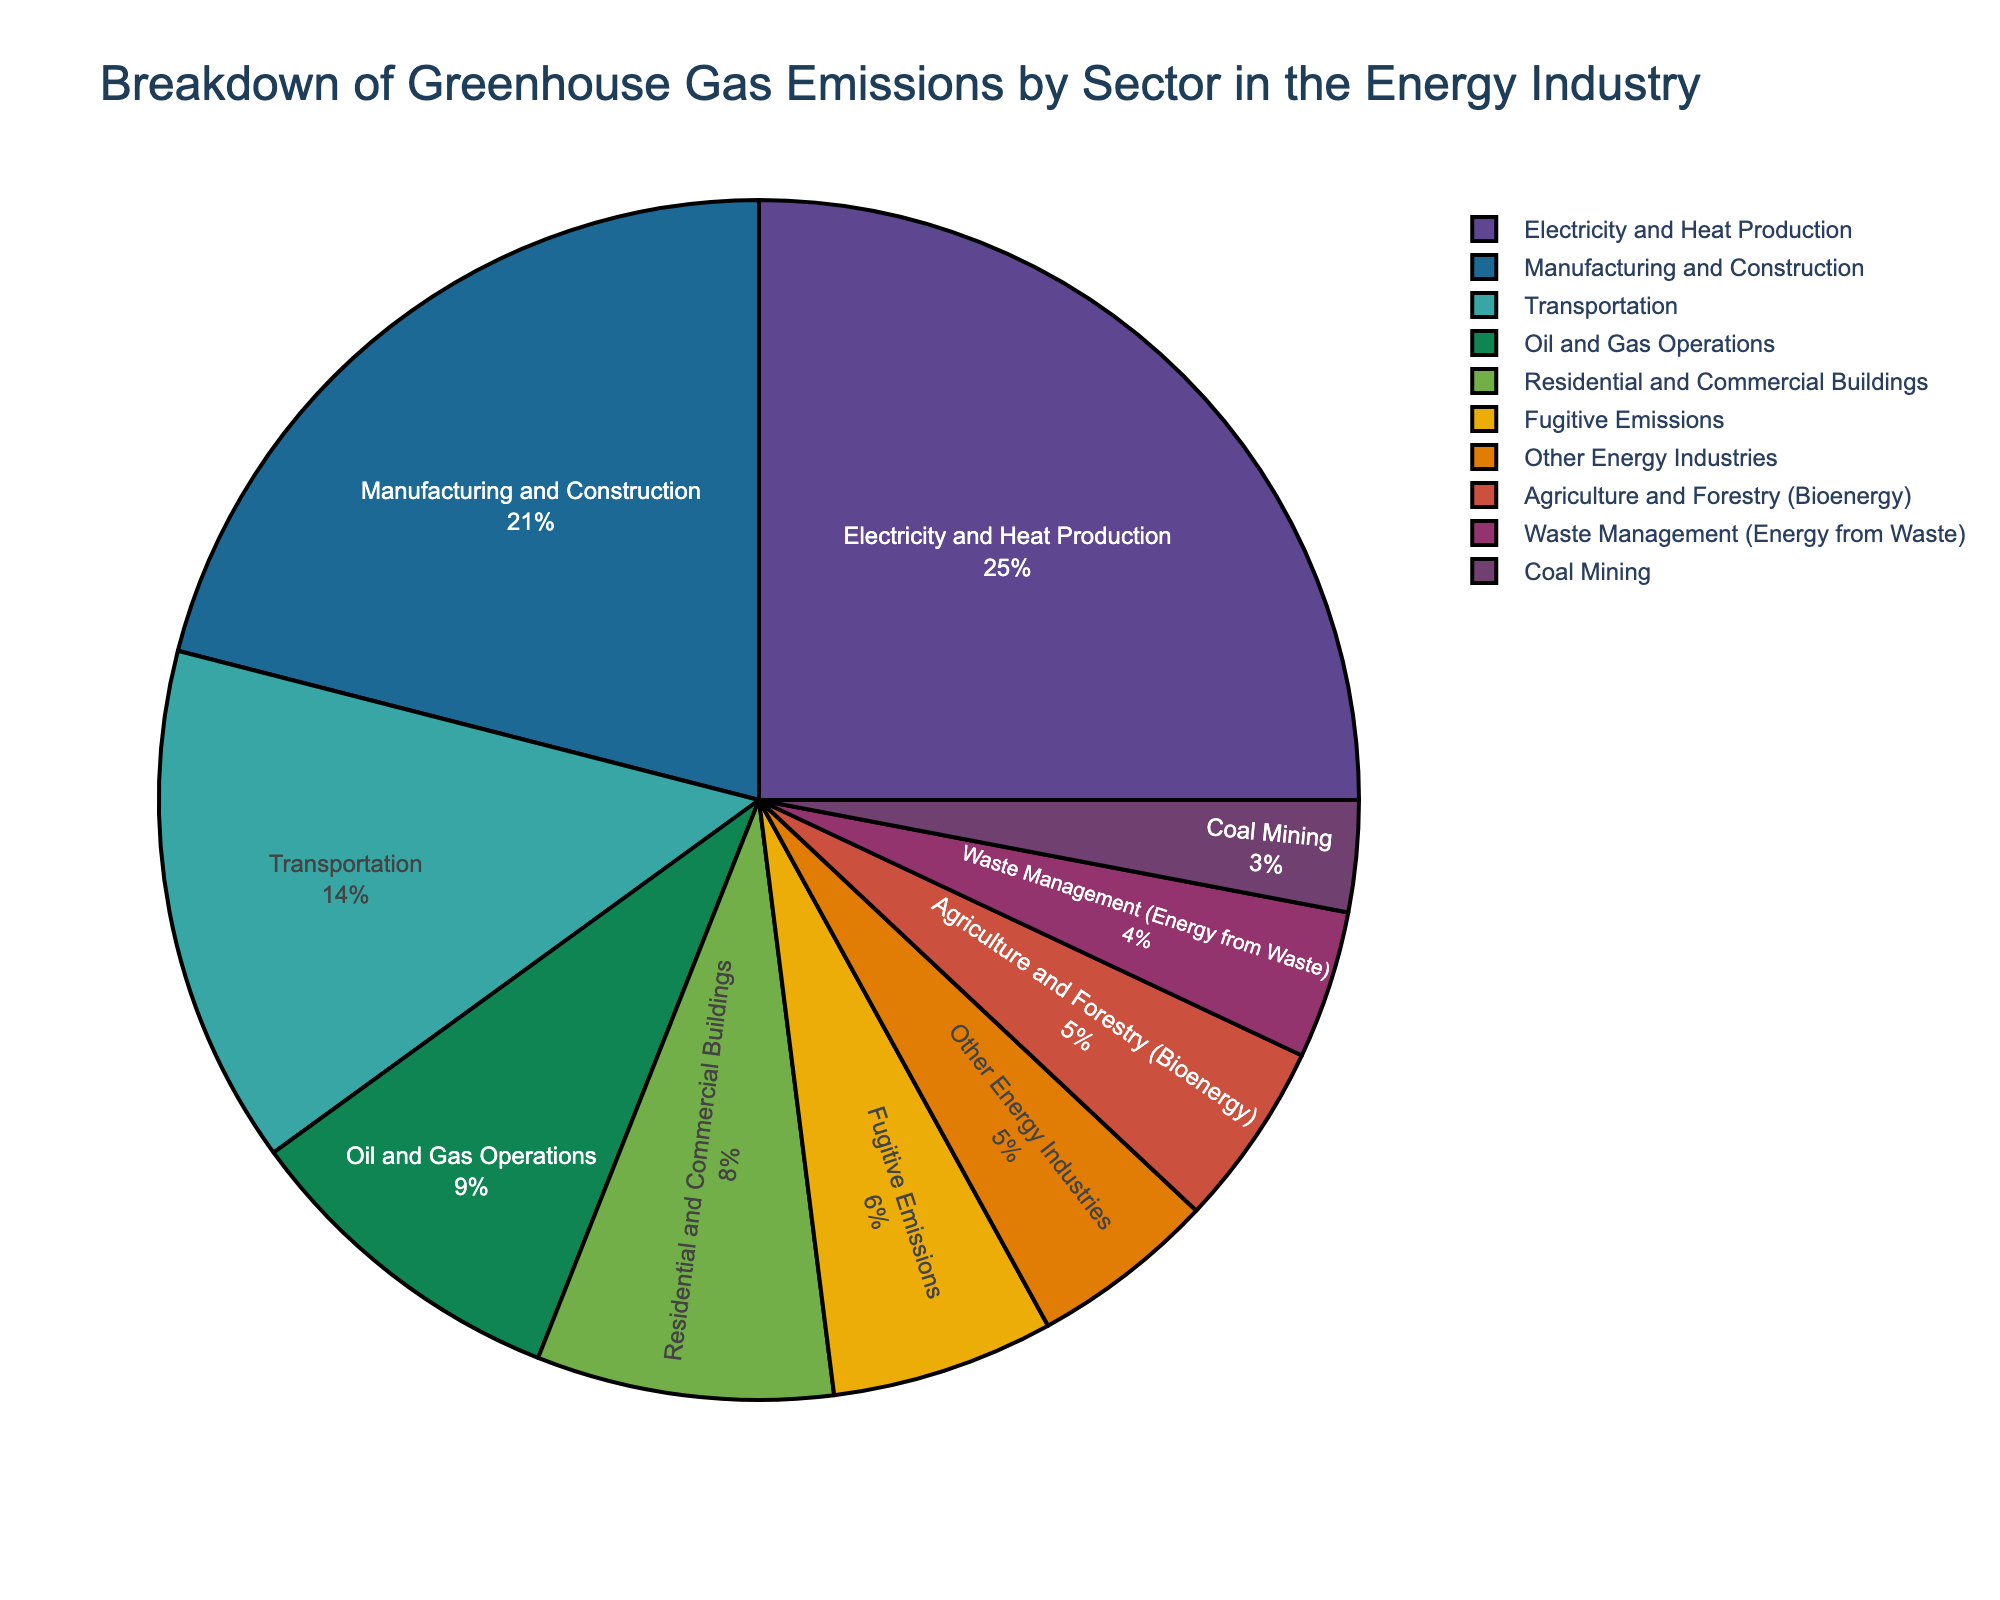Which sector contributes the most to greenhouse gas emissions in the energy industry? The sector contributing the most can be determined by identifying the largest slice in the pie chart, which belongs to the "Electricity and Heat Production" sector.
Answer: Electricity and Heat Production Which sectors contribute less than 10% of the greenhouse gas emissions each? From the pie chart, we identify all sectors with a percentage less than 10%. These sectors are "Fugitive Emissions", "Coal Mining", "Other Energy Industries", "Agriculture and Forestry (Bioenergy)", and "Waste Management (Energy from Waste)".
Answer: Fugitive Emissions, Coal Mining, Other Energy Industries, Agriculture and Forestry (Bioenergy), Waste Management (Energy from Waste) What is the combined percentage of greenhouse gas emissions from the "Transportation" and "Residential and Commercial Buildings" sectors? We sum the percentages of the "Transportation" (14%) and "Residential and Commercial Buildings" (8%) sectors. The combined percentage is 14 + 8 = 22%.
Answer: 22% How much greater is the percentage of emissions from "Manufacturing and Construction" compared to "Waste Management (Energy from Waste)"? We find the difference between the percentages of "Manufacturing and Construction" (21%) and "Waste Management (Energy from Waste)" (4%). The difference is 21 - 4 = 17%.
Answer: 17% Which sectors together contribute exactly 10% of the greenhouse gas emissions? We look for sectors that together sum up to 10%. The sum of "Coal Mining" (3%) and "Waste Management (Energy from Waste)" (4%) is 7%, so we try the next possible pair. The sum of "Fugitive Emissions" (6%) and "Other Energy Industries" (5%) is 11%, so another candidate pair doesn’t fit. The correct pair is "Agriculture and Forestry (Bioenergy)" (5%) and "Waste Management (Energy from Waste)" (4%) summing up to 9%. Although this pair is closest to 10%.
Answer: None, closest is Agriculture and Forestry (Bioenergy) and Waste Management What is the total percentage of emissions from the sectors that individually represent less than 5% of the total? We sum the percentages of the sectors "Coal Mining" (3%), "Waste Management (Energy from Waste)" (4%), and none of the others fit as they're 5% or higher. 3 + 4 = 7%.
Answer: 7% Is the percentage of emissions from "Electricity and Heat Production" greater than the combined percentage from "Oil and Gas Operations" and "Residential and Commercial Buildings"? First, sum the percentages of "Oil and Gas Operations" (9%) and "Residential and Commercial Buildings" (8%), which equals 17%. Compare this with the sector "Electricity and Heat Production" (25%). Since 25% is greater than 17%, the answer is yes.
Answer: Yes If you combine the emissions percentages of all sectors except "Electricity and Heat Production", does the combined total exceed 50%? Summing the percentages of all sectors except "Electricity and Heat Production", i.e., 14% + 21% + 6% + 9% + 3% + 5% + 8% + 5% + 4% = 75%. Yes, 75% is greater than 50%.
Answer: Yes 